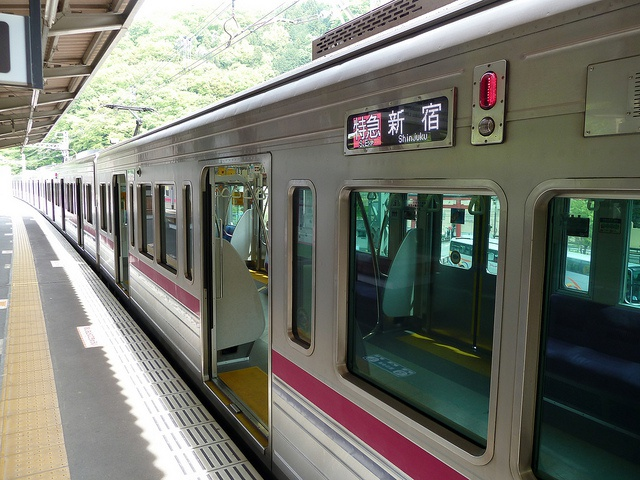Describe the objects in this image and their specific colors. I can see train in gray, black, darkgray, and lightgray tones and bench in gray, black, darkblue, and teal tones in this image. 